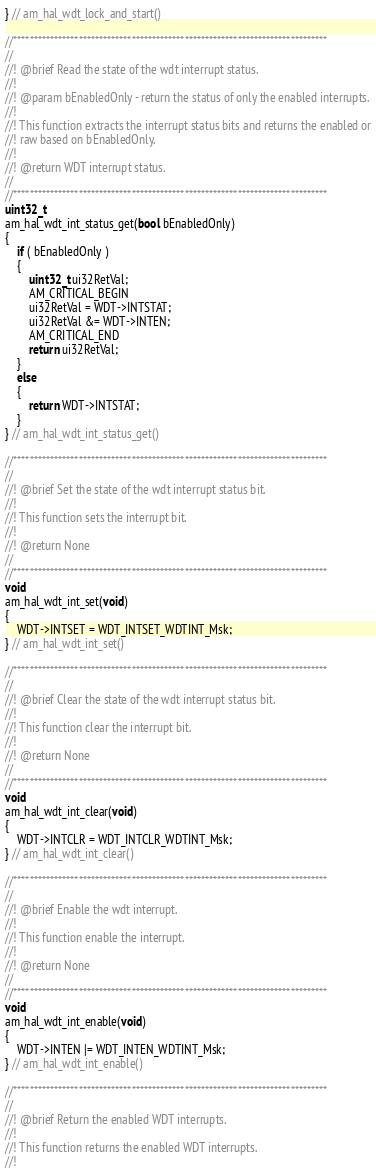Convert code to text. <code><loc_0><loc_0><loc_500><loc_500><_C_>} // am_hal_wdt_lock_and_start()

//*****************************************************************************
//
//! @brief Read the state of the wdt interrupt status.
//!
//! @param bEnabledOnly - return the status of only the enabled interrupts.
//!
//! This function extracts the interrupt status bits and returns the enabled or
//! raw based on bEnabledOnly.
//!
//! @return WDT interrupt status.
//
//*****************************************************************************
uint32_t
am_hal_wdt_int_status_get(bool bEnabledOnly)
{
    if ( bEnabledOnly )
    {
        uint32_t ui32RetVal;
        AM_CRITICAL_BEGIN
        ui32RetVal = WDT->INTSTAT;
        ui32RetVal &= WDT->INTEN;
        AM_CRITICAL_END
        return ui32RetVal;
    }
    else
    {
        return WDT->INTSTAT;
    }
} // am_hal_wdt_int_status_get()

//*****************************************************************************
//
//! @brief Set the state of the wdt interrupt status bit.
//!
//! This function sets the interrupt bit.
//!
//! @return None
//
//*****************************************************************************
void
am_hal_wdt_int_set(void)
{
    WDT->INTSET = WDT_INTSET_WDTINT_Msk;
} // am_hal_wdt_int_set()

//*****************************************************************************
//
//! @brief Clear the state of the wdt interrupt status bit.
//!
//! This function clear the interrupt bit.
//!
//! @return None
//
//*****************************************************************************
void
am_hal_wdt_int_clear(void)
{
    WDT->INTCLR = WDT_INTCLR_WDTINT_Msk;
} // am_hal_wdt_int_clear()

//*****************************************************************************
//
//! @brief Enable the wdt interrupt.
//!
//! This function enable the interrupt.
//!
//! @return None
//
//*****************************************************************************
void
am_hal_wdt_int_enable(void)
{
    WDT->INTEN |= WDT_INTEN_WDTINT_Msk;
} // am_hal_wdt_int_enable()

//*****************************************************************************
//
//! @brief Return the enabled WDT interrupts.
//!
//! This function returns the enabled WDT interrupts.
//!</code> 